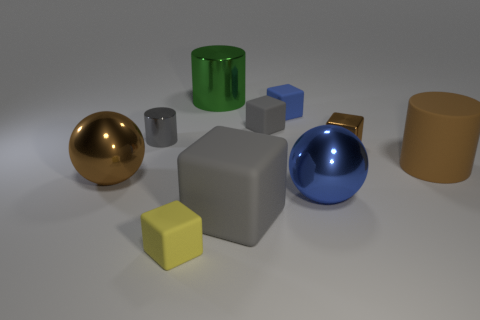Is the size of the yellow block the same as the brown metal object that is to the left of the tiny yellow object?
Provide a succinct answer. No. Is there any other thing that is the same shape as the yellow thing?
Offer a very short reply. Yes. How big is the blue block?
Ensure brevity in your answer.  Small. Are there fewer tiny brown things that are in front of the blue metallic ball than large gray things?
Offer a terse response. Yes. Do the gray cylinder and the brown matte cylinder have the same size?
Offer a terse response. No. Are there any other things that have the same size as the brown metallic block?
Ensure brevity in your answer.  Yes. There is a big cylinder that is made of the same material as the big blue ball; what is its color?
Keep it short and to the point. Green. Are there fewer large brown spheres behind the big metallic cylinder than gray matte blocks right of the blue block?
Give a very brief answer. No. How many tiny metal balls have the same color as the big block?
Make the answer very short. 0. What is the material of the big ball that is the same color as the big rubber cylinder?
Your answer should be compact. Metal. 